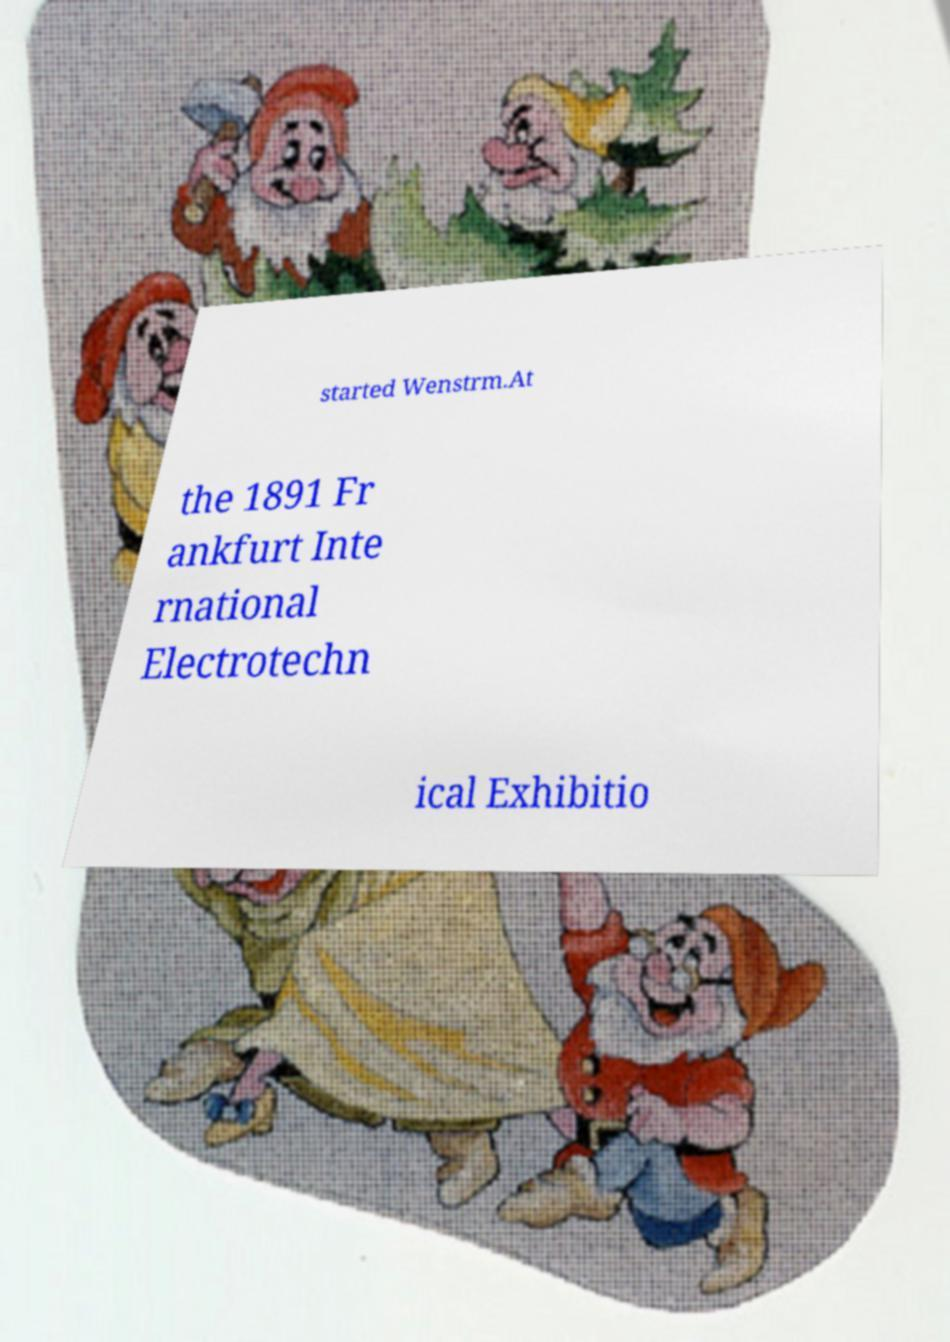Please read and relay the text visible in this image. What does it say? started Wenstrm.At the 1891 Fr ankfurt Inte rnational Electrotechn ical Exhibitio 